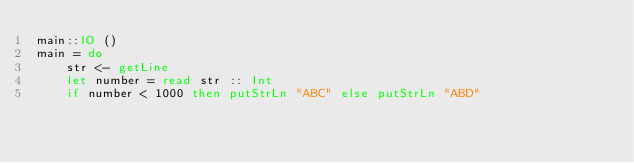<code> <loc_0><loc_0><loc_500><loc_500><_Haskell_>main::IO ()
main = do
    str <- getLine
    let number = read str :: Int
    if number < 1000 then putStrLn "ABC" else putStrLn "ABD"
</code> 